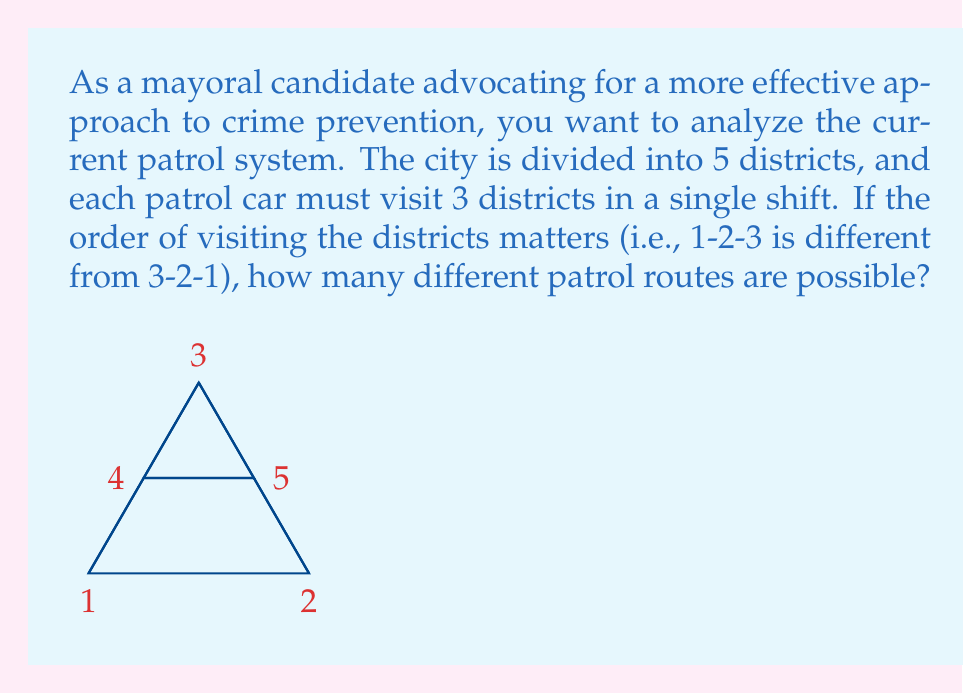Can you answer this question? Let's approach this step-by-step using combinatorics:

1) This is a permutation problem, as the order matters.

2) We need to select 3 districts out of 5, and arrange them in order.

3) This can be solved using the permutation formula:
   $$P(n,r) = \frac{n!}{(n-r)!}$$
   where n is the total number of districts and r is the number of districts visited.

4) In this case, n = 5 and r = 3.

5) Plugging these values into the formula:
   $$P(5,3) = \frac{5!}{(5-3)!} = \frac{5!}{2!}$$

6) Expanding this:
   $$\frac{5 \times 4 \times 3 \times 2!}{2!} = 5 \times 4 \times 3 = 60$$

Therefore, there are 60 possible patrol routes.

This analysis shows that the current system allows for a significant number of route variations, which could be used to argue for or against the effectiveness of the current patrol strategy.
Answer: 60 possible patrol routes 